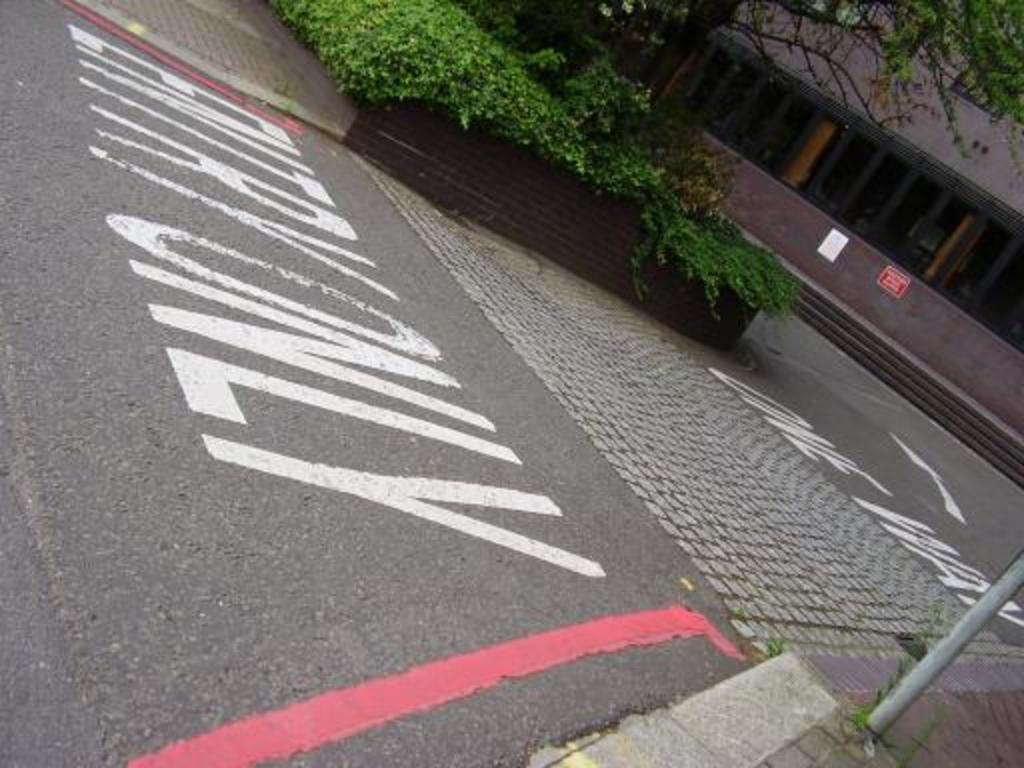Please provide a concise description of this image. In this image there is a road and we can see plants. In the background there is a building and a tree. At the bottom there is a pole. 